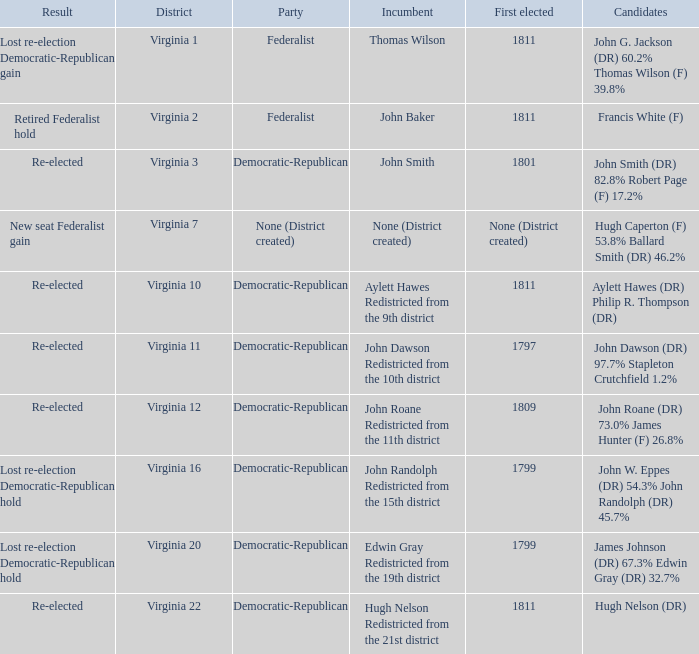Could you parse the entire table as a dict? {'header': ['Result', 'District', 'Party', 'Incumbent', 'First elected', 'Candidates'], 'rows': [['Lost re-election Democratic-Republican gain', 'Virginia 1', 'Federalist', 'Thomas Wilson', '1811', 'John G. Jackson (DR) 60.2% Thomas Wilson (F) 39.8%'], ['Retired Federalist hold', 'Virginia 2', 'Federalist', 'John Baker', '1811', 'Francis White (F)'], ['Re-elected', 'Virginia 3', 'Democratic-Republican', 'John Smith', '1801', 'John Smith (DR) 82.8% Robert Page (F) 17.2%'], ['New seat Federalist gain', 'Virginia 7', 'None (District created)', 'None (District created)', 'None (District created)', 'Hugh Caperton (F) 53.8% Ballard Smith (DR) 46.2%'], ['Re-elected', 'Virginia 10', 'Democratic-Republican', 'Aylett Hawes Redistricted from the 9th district', '1811', 'Aylett Hawes (DR) Philip R. Thompson (DR)'], ['Re-elected', 'Virginia 11', 'Democratic-Republican', 'John Dawson Redistricted from the 10th district', '1797', 'John Dawson (DR) 97.7% Stapleton Crutchfield 1.2%'], ['Re-elected', 'Virginia 12', 'Democratic-Republican', 'John Roane Redistricted from the 11th district', '1809', 'John Roane (DR) 73.0% James Hunter (F) 26.8%'], ['Lost re-election Democratic-Republican hold', 'Virginia 16', 'Democratic-Republican', 'John Randolph Redistricted from the 15th district', '1799', 'John W. Eppes (DR) 54.3% John Randolph (DR) 45.7%'], ['Lost re-election Democratic-Republican hold', 'Virginia 20', 'Democratic-Republican', 'Edwin Gray Redistricted from the 19th district', '1799', 'James Johnson (DR) 67.3% Edwin Gray (DR) 32.7%'], ['Re-elected', 'Virginia 22', 'Democratic-Republican', 'Hugh Nelson Redistricted from the 21st district', '1811', 'Hugh Nelson (DR)']]} Name the party for virginia 12 Democratic-Republican. 